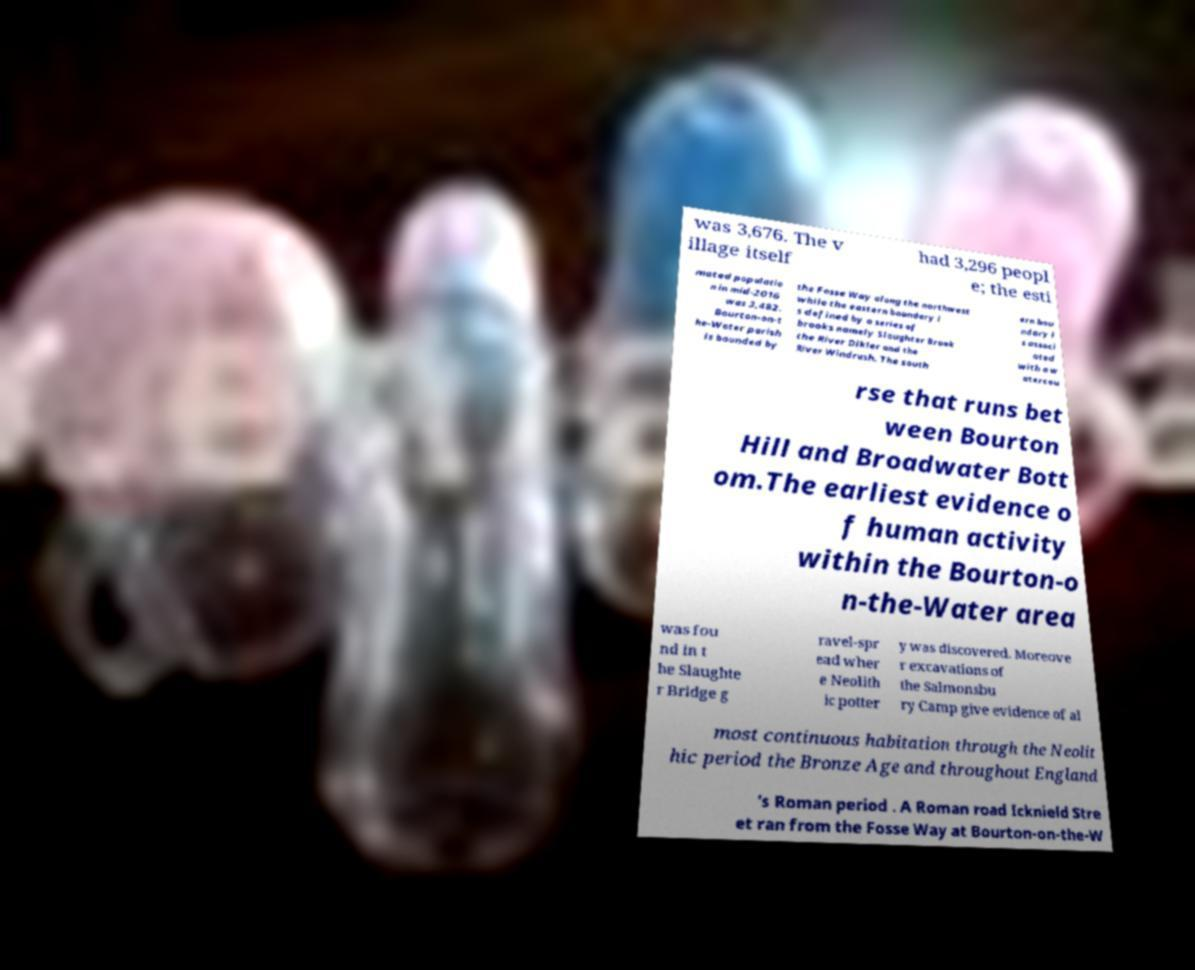Can you read and provide the text displayed in the image?This photo seems to have some interesting text. Can you extract and type it out for me? was 3,676. The v illage itself had 3,296 peopl e; the esti mated populatio n in mid-2016 was 3,482. Bourton-on-t he-Water parish is bounded by the Fosse Way along the northwest while the eastern boundary i s defined by a series of brooks namely Slaughter Brook the River Dikler and the River Windrush. The south ern bou ndary i s associ ated with a w atercou rse that runs bet ween Bourton Hill and Broadwater Bott om.The earliest evidence o f human activity within the Bourton-o n-the-Water area was fou nd in t he Slaughte r Bridge g ravel-spr ead wher e Neolith ic potter y was discovered. Moreove r excavations of the Salmonsbu ry Camp give evidence of al most continuous habitation through the Neolit hic period the Bronze Age and throughout England 's Roman period . A Roman road Icknield Stre et ran from the Fosse Way at Bourton-on-the-W 